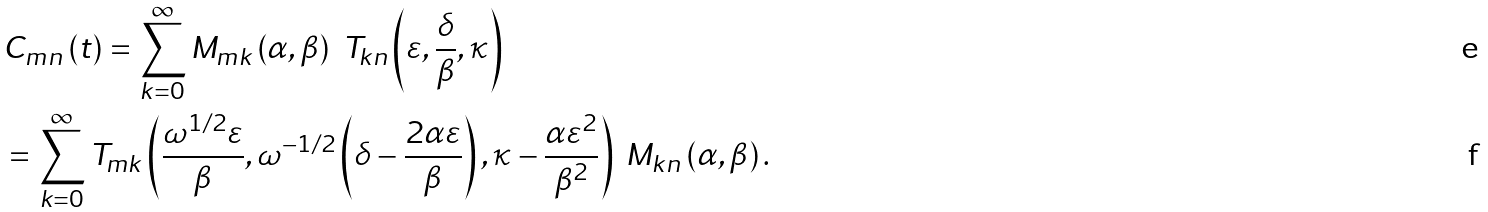Convert formula to latex. <formula><loc_0><loc_0><loc_500><loc_500>& C _ { m n } \left ( t \right ) = \sum _ { k = 0 } ^ { \infty } M _ { m k } \left ( \alpha , \beta \right ) \ T _ { k n } \left ( \varepsilon , \frac { \delta } { \beta } , \kappa \right ) \\ & = \sum _ { k = 0 } ^ { \infty } T _ { m k } \left ( \frac { \omega ^ { 1 / 2 } \varepsilon } { \beta } , \omega ^ { - 1 / 2 } \left ( \delta - \frac { 2 \alpha \varepsilon } { \beta } \right ) , \kappa - \frac { \alpha \varepsilon ^ { 2 } } { \beta ^ { 2 } } \right ) \ M _ { k n } \left ( \alpha , \beta \right ) .</formula> 